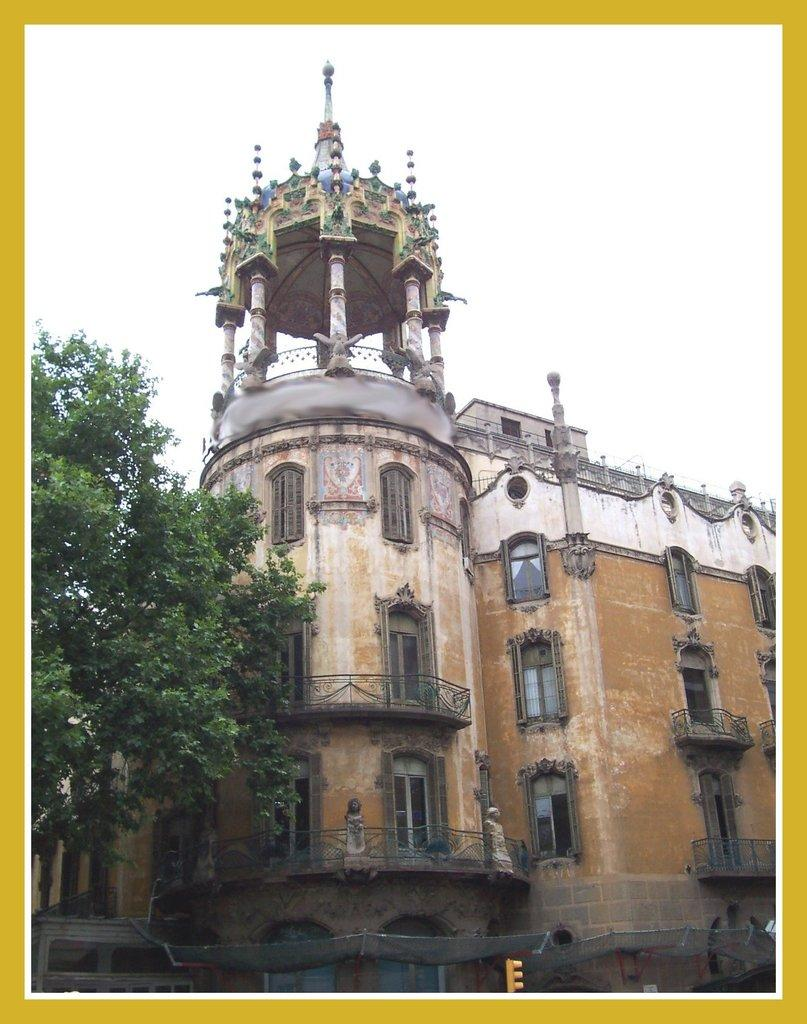What type of image is being described? The image is a poster card. What natural element can be seen in the image? There is a tree in the image. What man-made structure is present in the image? There is a building in the image. What architectural feature can be seen in the image? There are windows in the image. What safety feature is present in the image? There is a railing in the image. What traffic control device is visible in the image? There is a traffic signal at the bottom of the image. What part of the natural environment is visible in the image? The sky is visible in the image. What type of ear is visible on the tree in the image? There is no ear present in the image, as it features a tree and other elements related to a scene or landscape. 